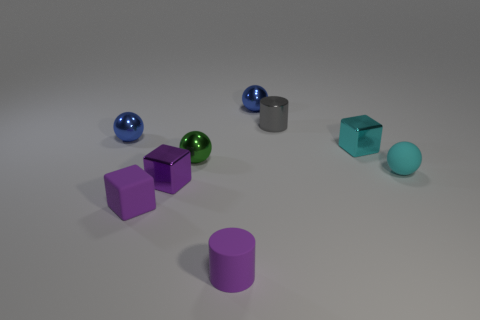Is the color of the small rubber cube the same as the matte cylinder?
Give a very brief answer. Yes. There is a sphere on the right side of the gray object; what material is it?
Keep it short and to the point. Rubber. How many small things are gray metallic cylinders or metallic objects?
Your answer should be very brief. 6. What is the material of the other block that is the same color as the rubber cube?
Provide a short and direct response. Metal. Is there a small brown block made of the same material as the cyan block?
Make the answer very short. No. Does the blue metallic object right of the purple rubber cube have the same size as the cyan ball?
Your response must be concise. Yes. There is a small cylinder that is behind the shiny ball on the left side of the rubber cube; is there a tiny cyan metal cube that is on the right side of it?
Your answer should be very brief. Yes. How many metal objects are green objects or small purple cubes?
Your answer should be very brief. 2. How many other things are the same shape as the tiny gray object?
Offer a very short reply. 1. Are there more big cyan shiny cubes than small green shiny spheres?
Make the answer very short. No. 